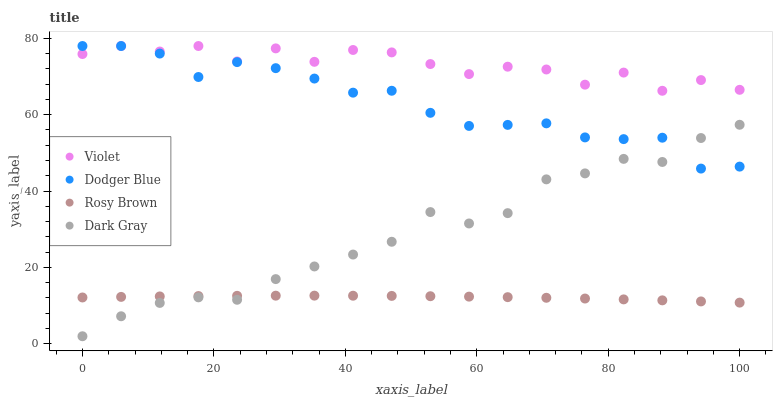Does Rosy Brown have the minimum area under the curve?
Answer yes or no. Yes. Does Violet have the maximum area under the curve?
Answer yes or no. Yes. Does Dodger Blue have the minimum area under the curve?
Answer yes or no. No. Does Dodger Blue have the maximum area under the curve?
Answer yes or no. No. Is Rosy Brown the smoothest?
Answer yes or no. Yes. Is Violet the roughest?
Answer yes or no. Yes. Is Dodger Blue the smoothest?
Answer yes or no. No. Is Dodger Blue the roughest?
Answer yes or no. No. Does Dark Gray have the lowest value?
Answer yes or no. Yes. Does Rosy Brown have the lowest value?
Answer yes or no. No. Does Violet have the highest value?
Answer yes or no. Yes. Does Rosy Brown have the highest value?
Answer yes or no. No. Is Rosy Brown less than Dodger Blue?
Answer yes or no. Yes. Is Violet greater than Rosy Brown?
Answer yes or no. Yes. Does Dark Gray intersect Dodger Blue?
Answer yes or no. Yes. Is Dark Gray less than Dodger Blue?
Answer yes or no. No. Is Dark Gray greater than Dodger Blue?
Answer yes or no. No. Does Rosy Brown intersect Dodger Blue?
Answer yes or no. No. 